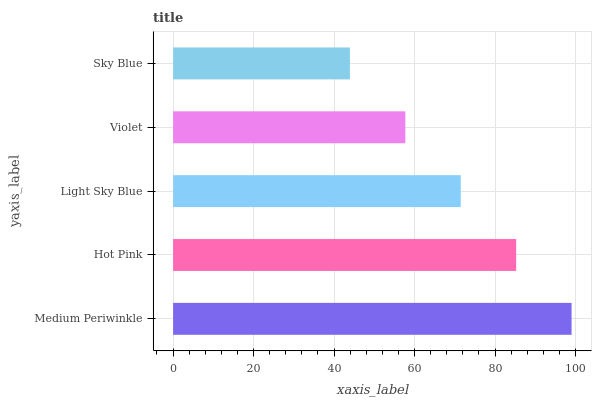Is Sky Blue the minimum?
Answer yes or no. Yes. Is Medium Periwinkle the maximum?
Answer yes or no. Yes. Is Hot Pink the minimum?
Answer yes or no. No. Is Hot Pink the maximum?
Answer yes or no. No. Is Medium Periwinkle greater than Hot Pink?
Answer yes or no. Yes. Is Hot Pink less than Medium Periwinkle?
Answer yes or no. Yes. Is Hot Pink greater than Medium Periwinkle?
Answer yes or no. No. Is Medium Periwinkle less than Hot Pink?
Answer yes or no. No. Is Light Sky Blue the high median?
Answer yes or no. Yes. Is Light Sky Blue the low median?
Answer yes or no. Yes. Is Violet the high median?
Answer yes or no. No. Is Hot Pink the low median?
Answer yes or no. No. 